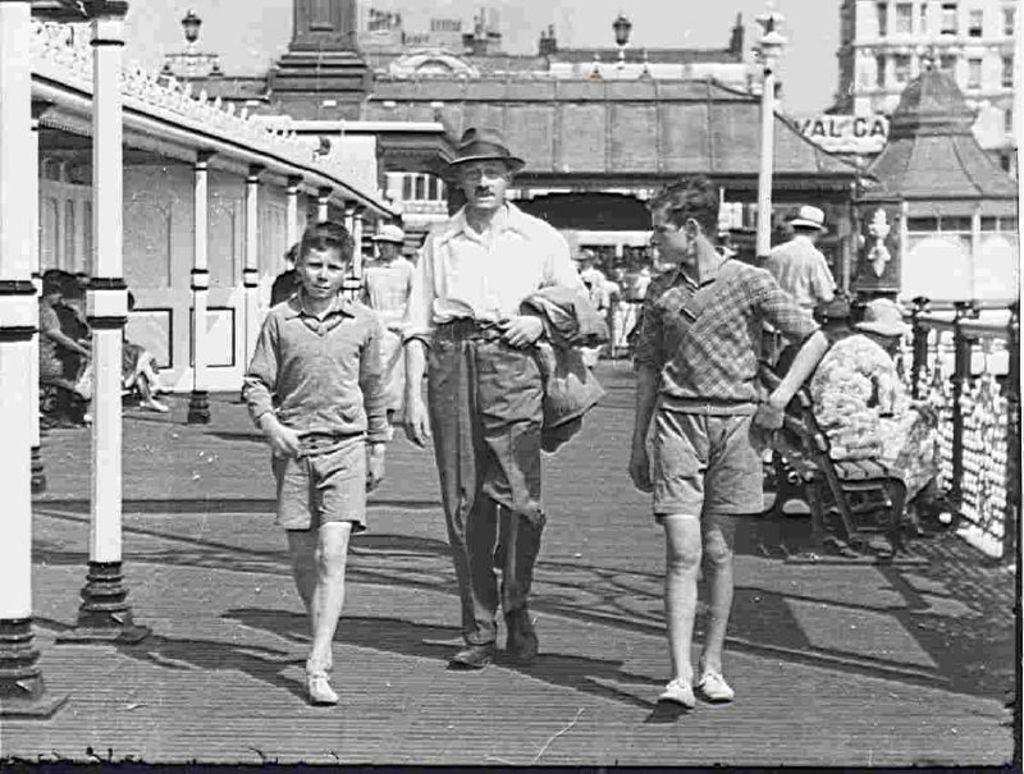What is the color scheme of the image? The image is black and white and old. How many people are in the foreground of the image? There are three people in the foreground. What architectural features can be seen in the image? There are pillars and buildings in the image. How many people are present in the image? There are many other people in the image, in addition to the three in the foreground. What are the people in the image doing? The people are walking on a path. What type of wound can be seen on one of the women in the image? There are no women present in the image, and no wounds can be seen on any of the people. 